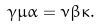Convert formula to latex. <formula><loc_0><loc_0><loc_500><loc_500>\gamma \mu \alpha = \nu \beta \kappa .</formula> 